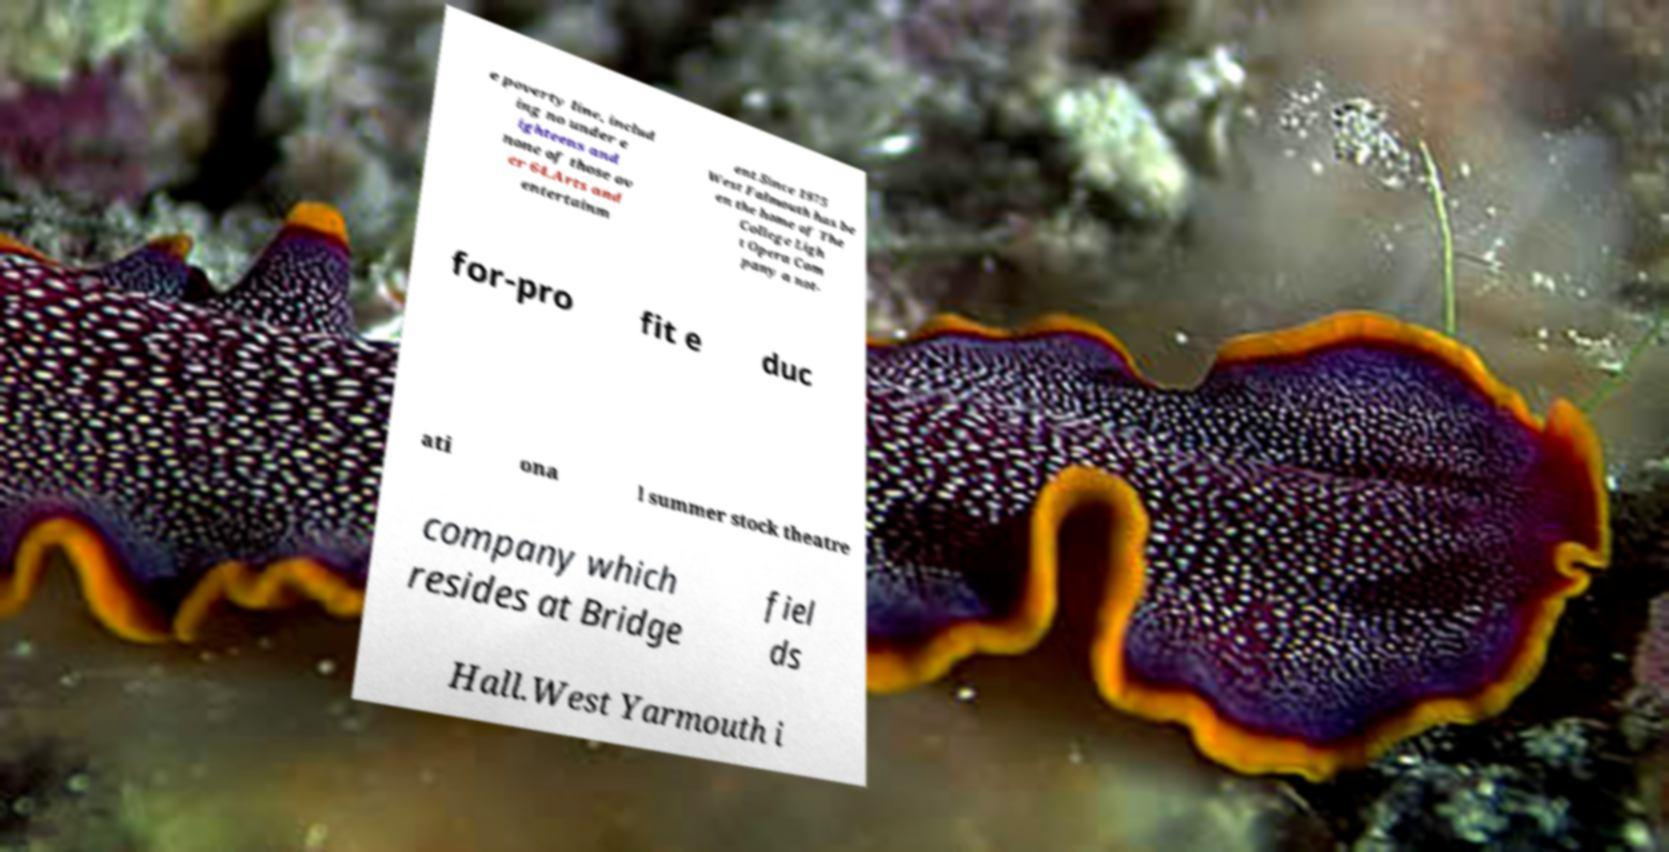Could you extract and type out the text from this image? e poverty line, includ ing no under e ighteens and none of those ov er 64.Arts and entertainm ent.Since 1975 West Falmouth has be en the home of The College Ligh t Opera Com pany a not- for-pro fit e duc ati ona l summer stock theatre company which resides at Bridge fiel ds Hall.West Yarmouth i 